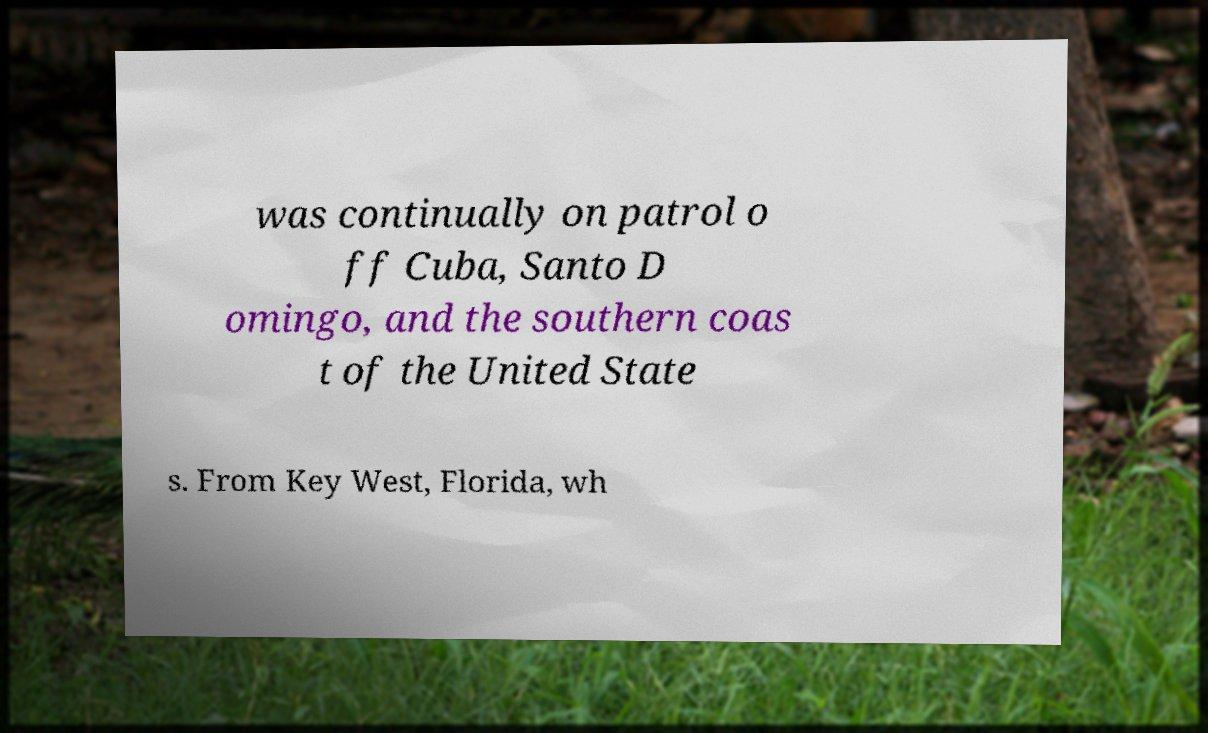Can you accurately transcribe the text from the provided image for me? was continually on patrol o ff Cuba, Santo D omingo, and the southern coas t of the United State s. From Key West, Florida, wh 